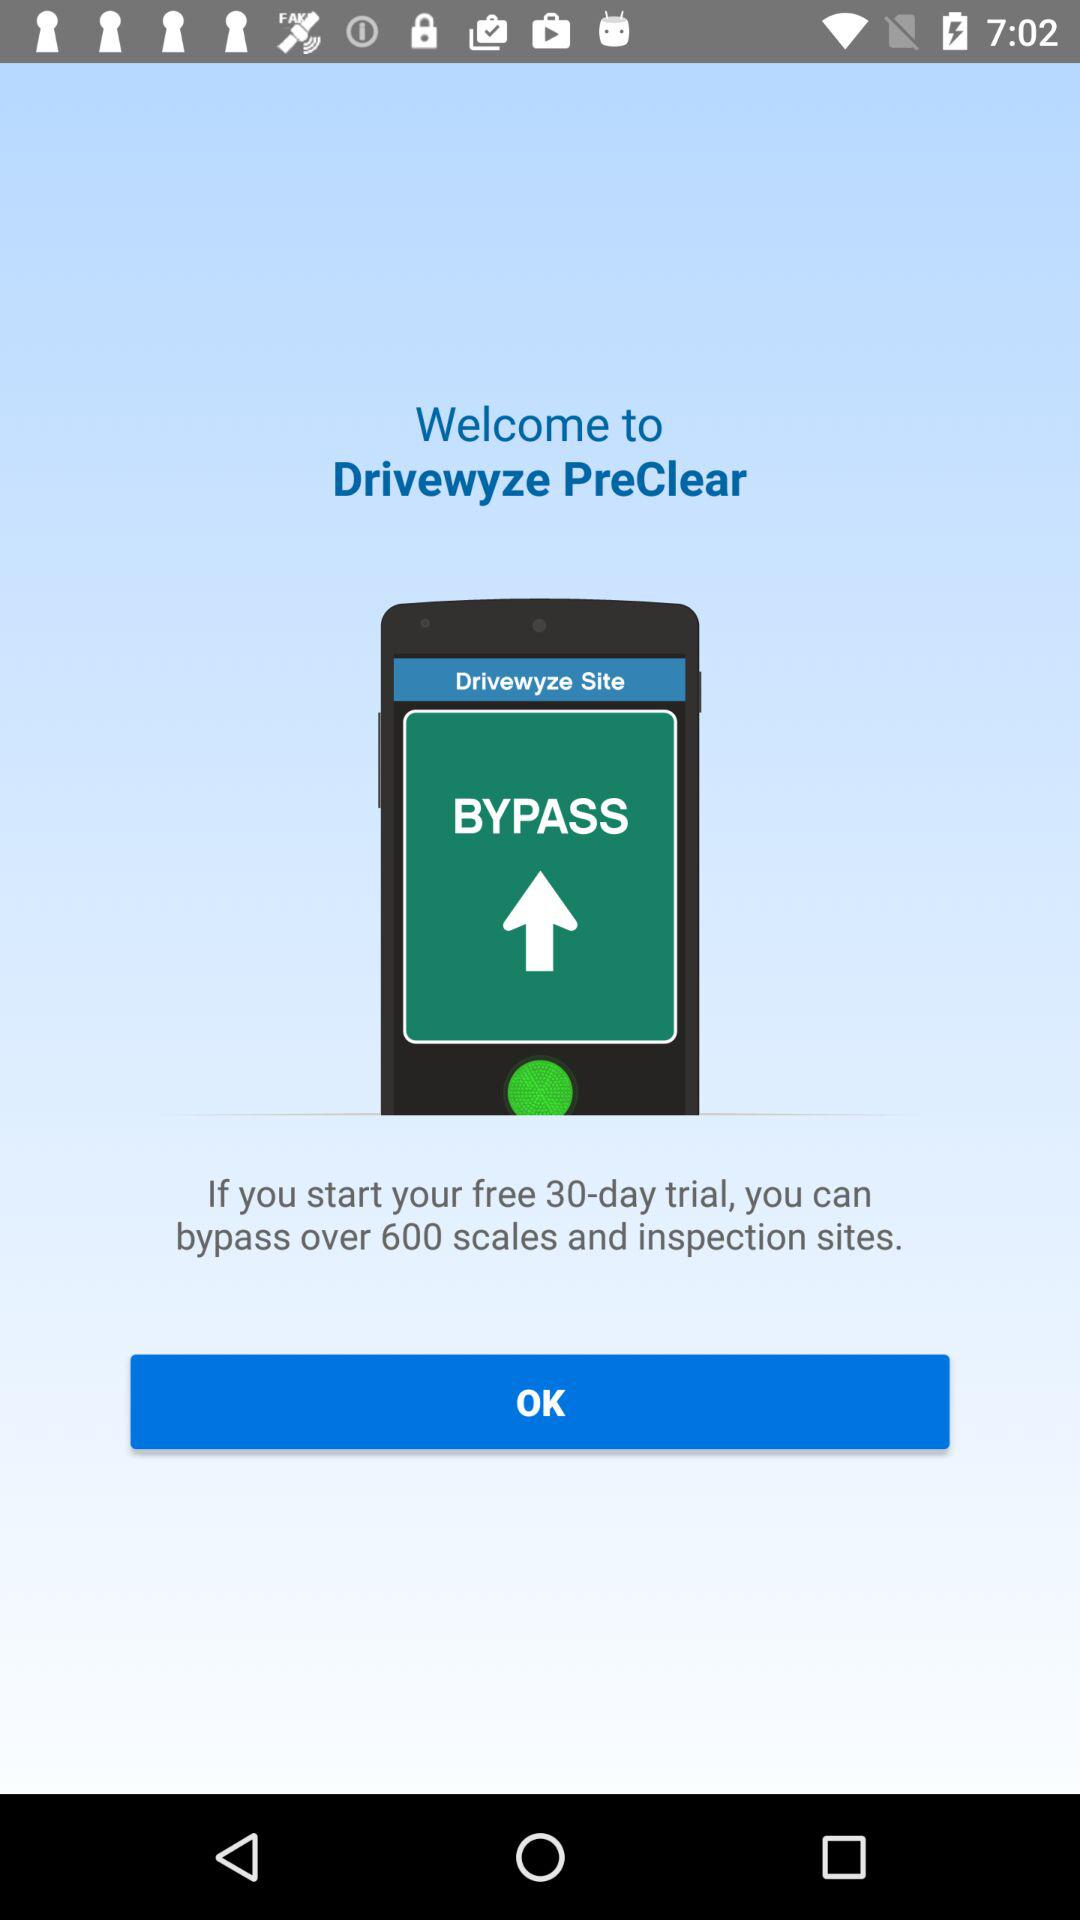What is the application name? The application name is "Drivewyze PreClear". 